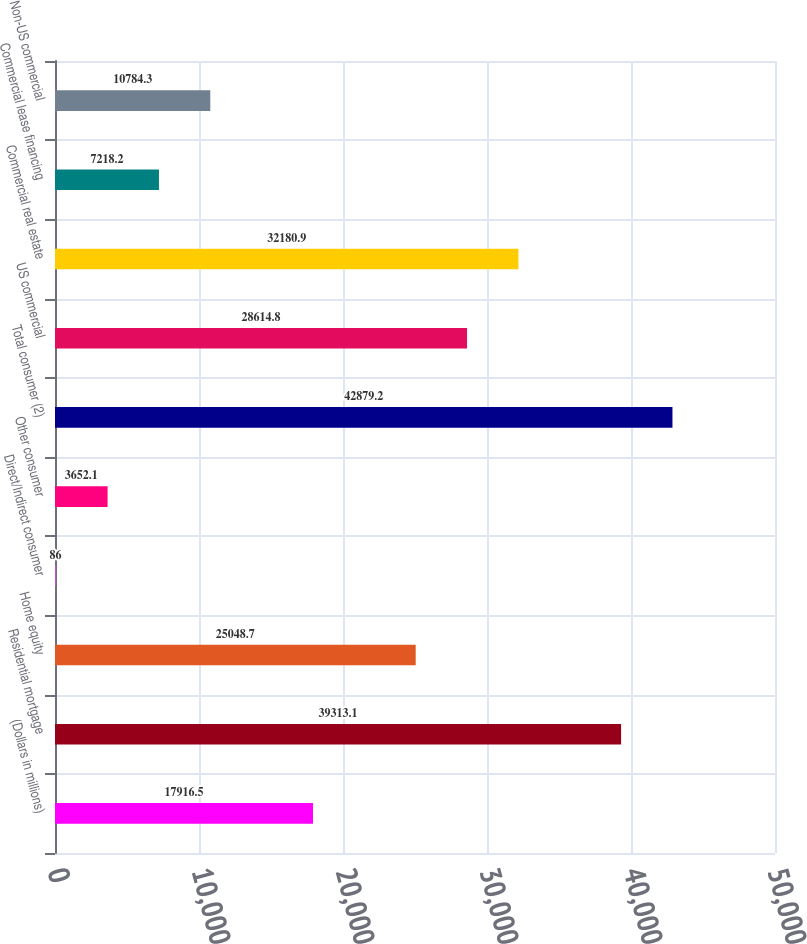Convert chart to OTSL. <chart><loc_0><loc_0><loc_500><loc_500><bar_chart><fcel>(Dollars in millions)<fcel>Residential mortgage<fcel>Home equity<fcel>Direct/Indirect consumer<fcel>Other consumer<fcel>Total consumer (2)<fcel>US commercial<fcel>Commercial real estate<fcel>Commercial lease financing<fcel>Non-US commercial<nl><fcel>17916.5<fcel>39313.1<fcel>25048.7<fcel>86<fcel>3652.1<fcel>42879.2<fcel>28614.8<fcel>32180.9<fcel>7218.2<fcel>10784.3<nl></chart> 